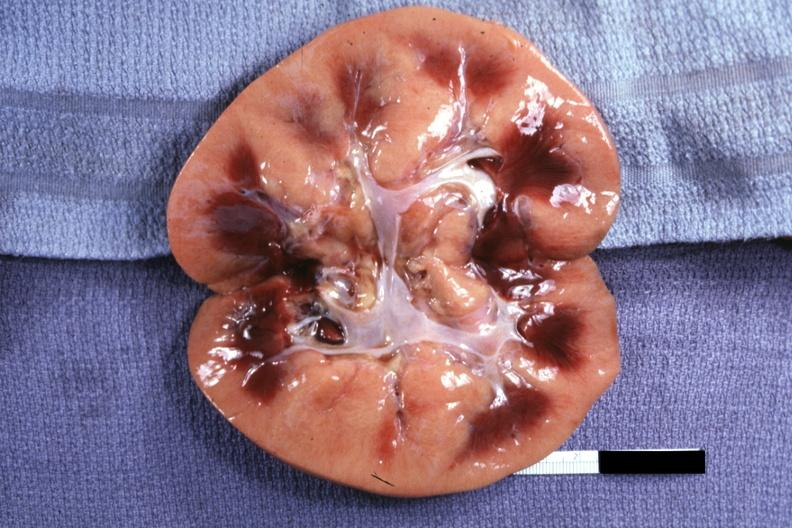where is this?
Answer the question using a single word or phrase. Urinary 